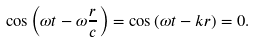Convert formula to latex. <formula><loc_0><loc_0><loc_500><loc_500>\cos \left ( \omega t - \omega \frac { r } { c } \right ) = \cos \left ( \omega t - k r \right ) = 0 .</formula> 